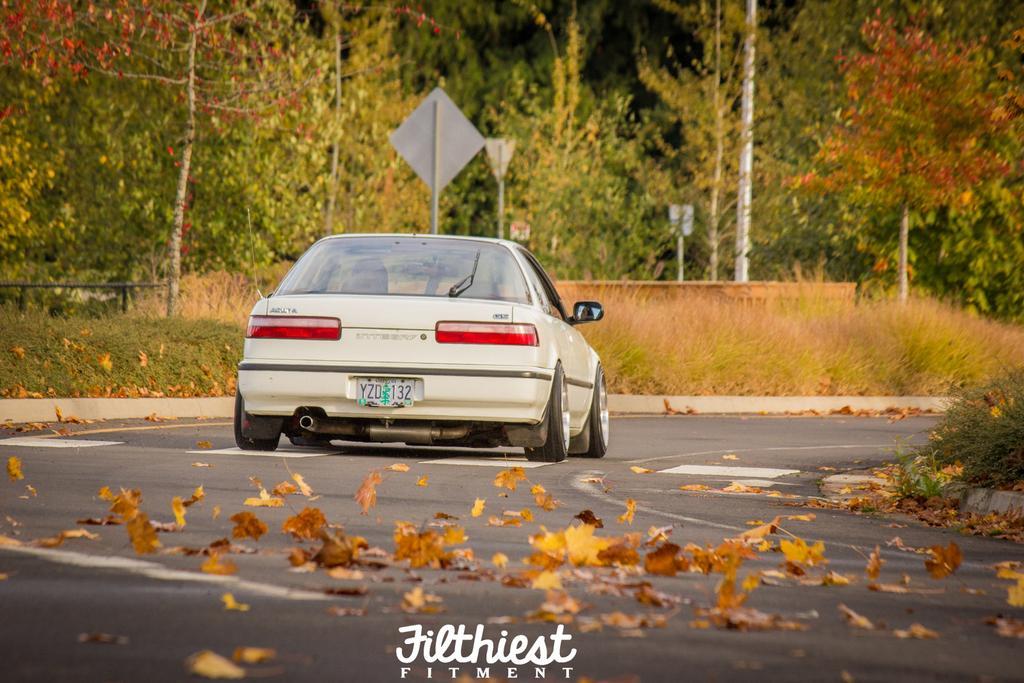In one or two sentences, can you explain what this image depicts? In this image I can see the vehicle and the dried leaves on the road. On both sides of the road I can see the grass. In the background I can see the boards and many trees. 